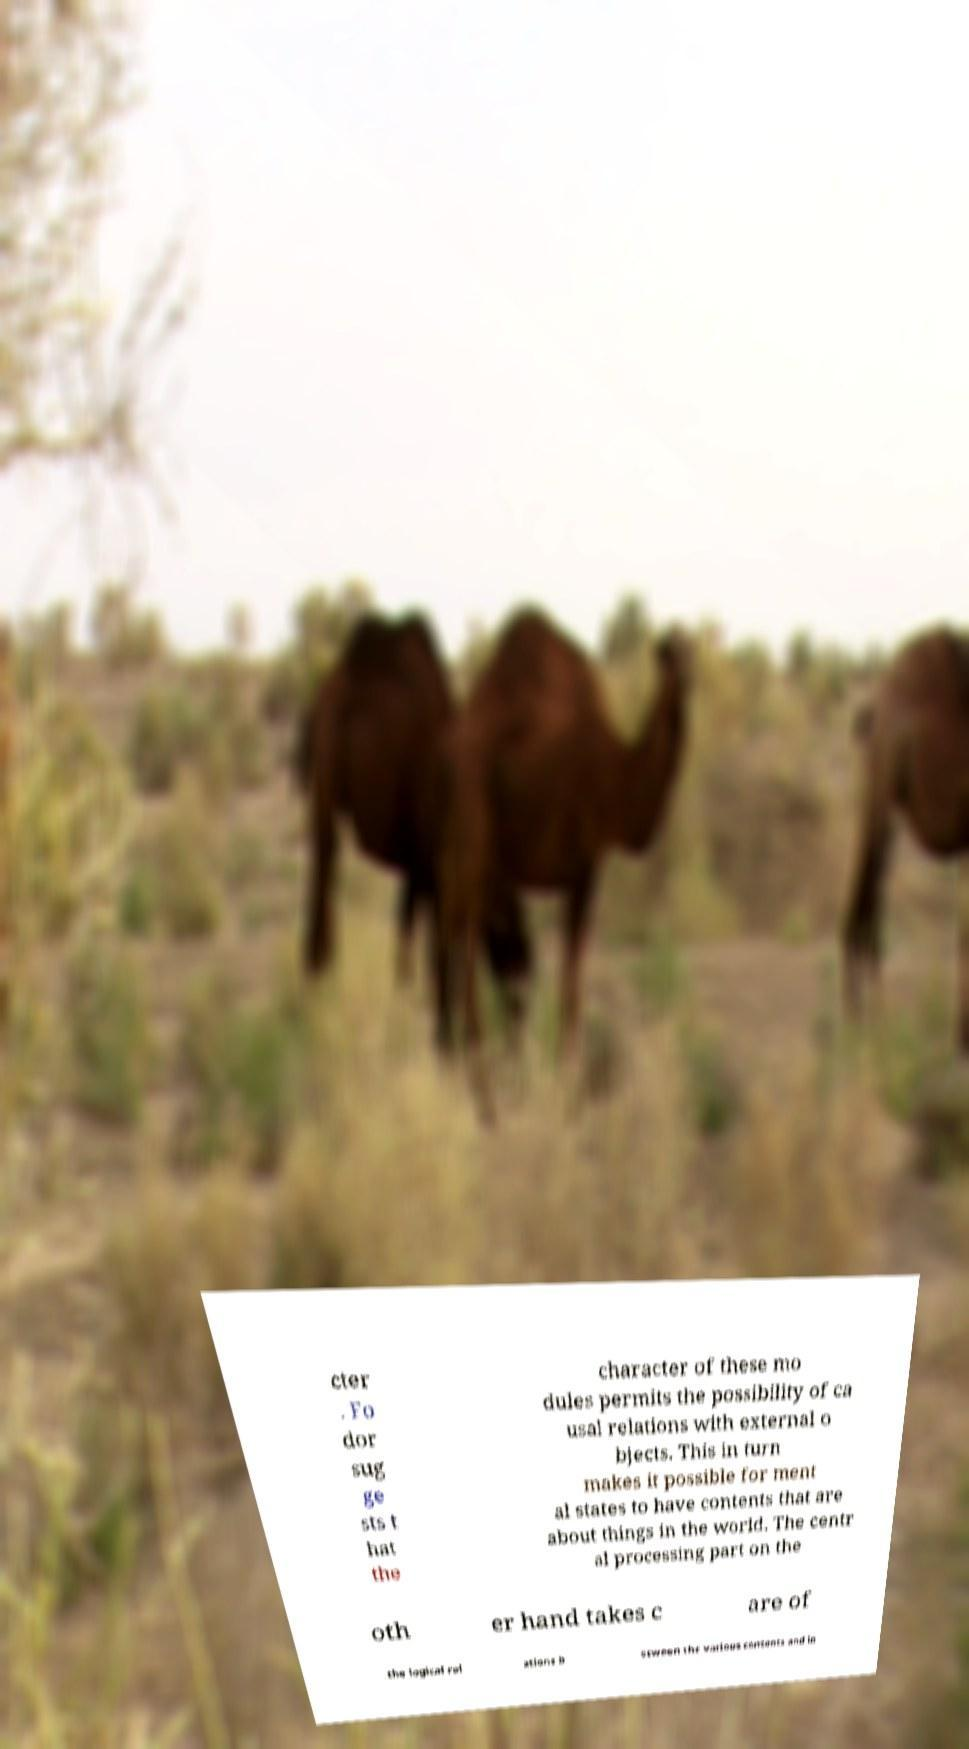Can you accurately transcribe the text from the provided image for me? cter . Fo dor sug ge sts t hat the character of these mo dules permits the possibility of ca usal relations with external o bjects. This in turn makes it possible for ment al states to have contents that are about things in the world. The centr al processing part on the oth er hand takes c are of the logical rel ations b etween the various contents and in 